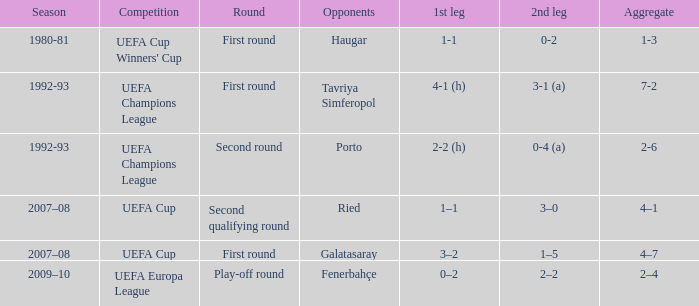What's the first phase where the rivals are galatasaray? 3–2. 